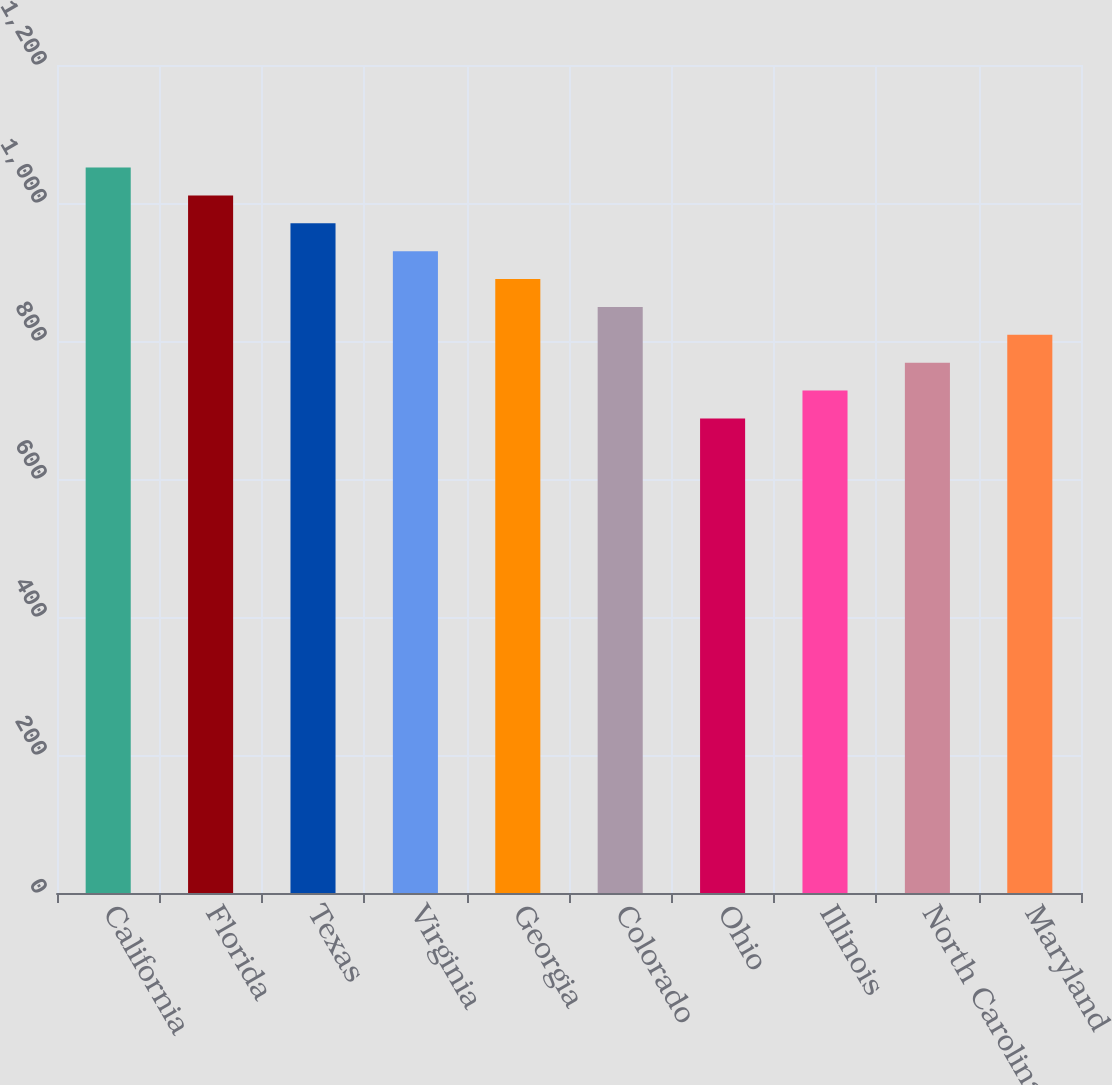<chart> <loc_0><loc_0><loc_500><loc_500><bar_chart><fcel>California<fcel>Florida<fcel>Texas<fcel>Virginia<fcel>Georgia<fcel>Colorado<fcel>Ohio<fcel>Illinois<fcel>North Carolina<fcel>Maryland<nl><fcel>1051.4<fcel>1011<fcel>970.6<fcel>930.2<fcel>889.8<fcel>849.4<fcel>687.8<fcel>728.2<fcel>768.6<fcel>809<nl></chart> 